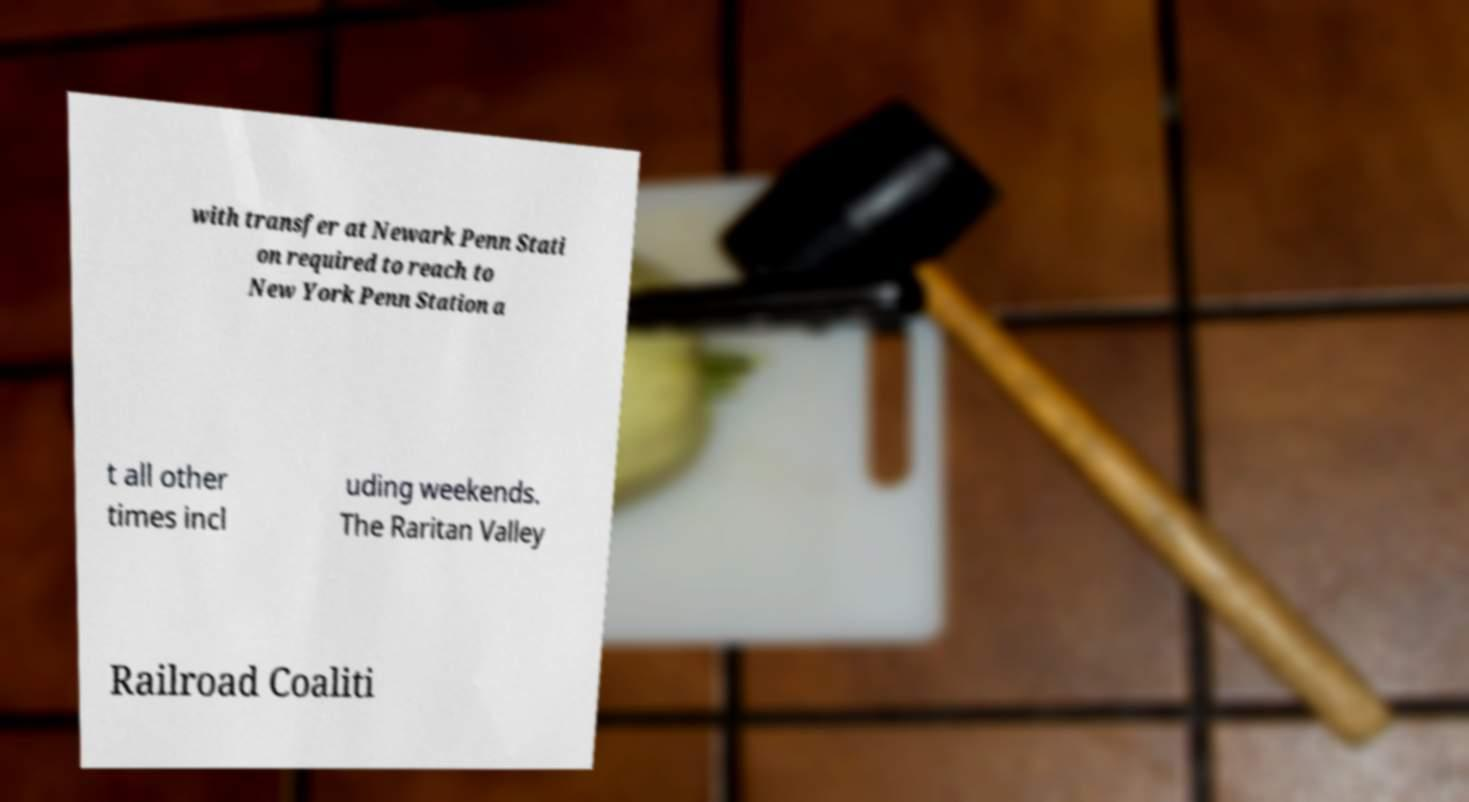Please read and relay the text visible in this image. What does it say? with transfer at Newark Penn Stati on required to reach to New York Penn Station a t all other times incl uding weekends. The Raritan Valley Railroad Coaliti 